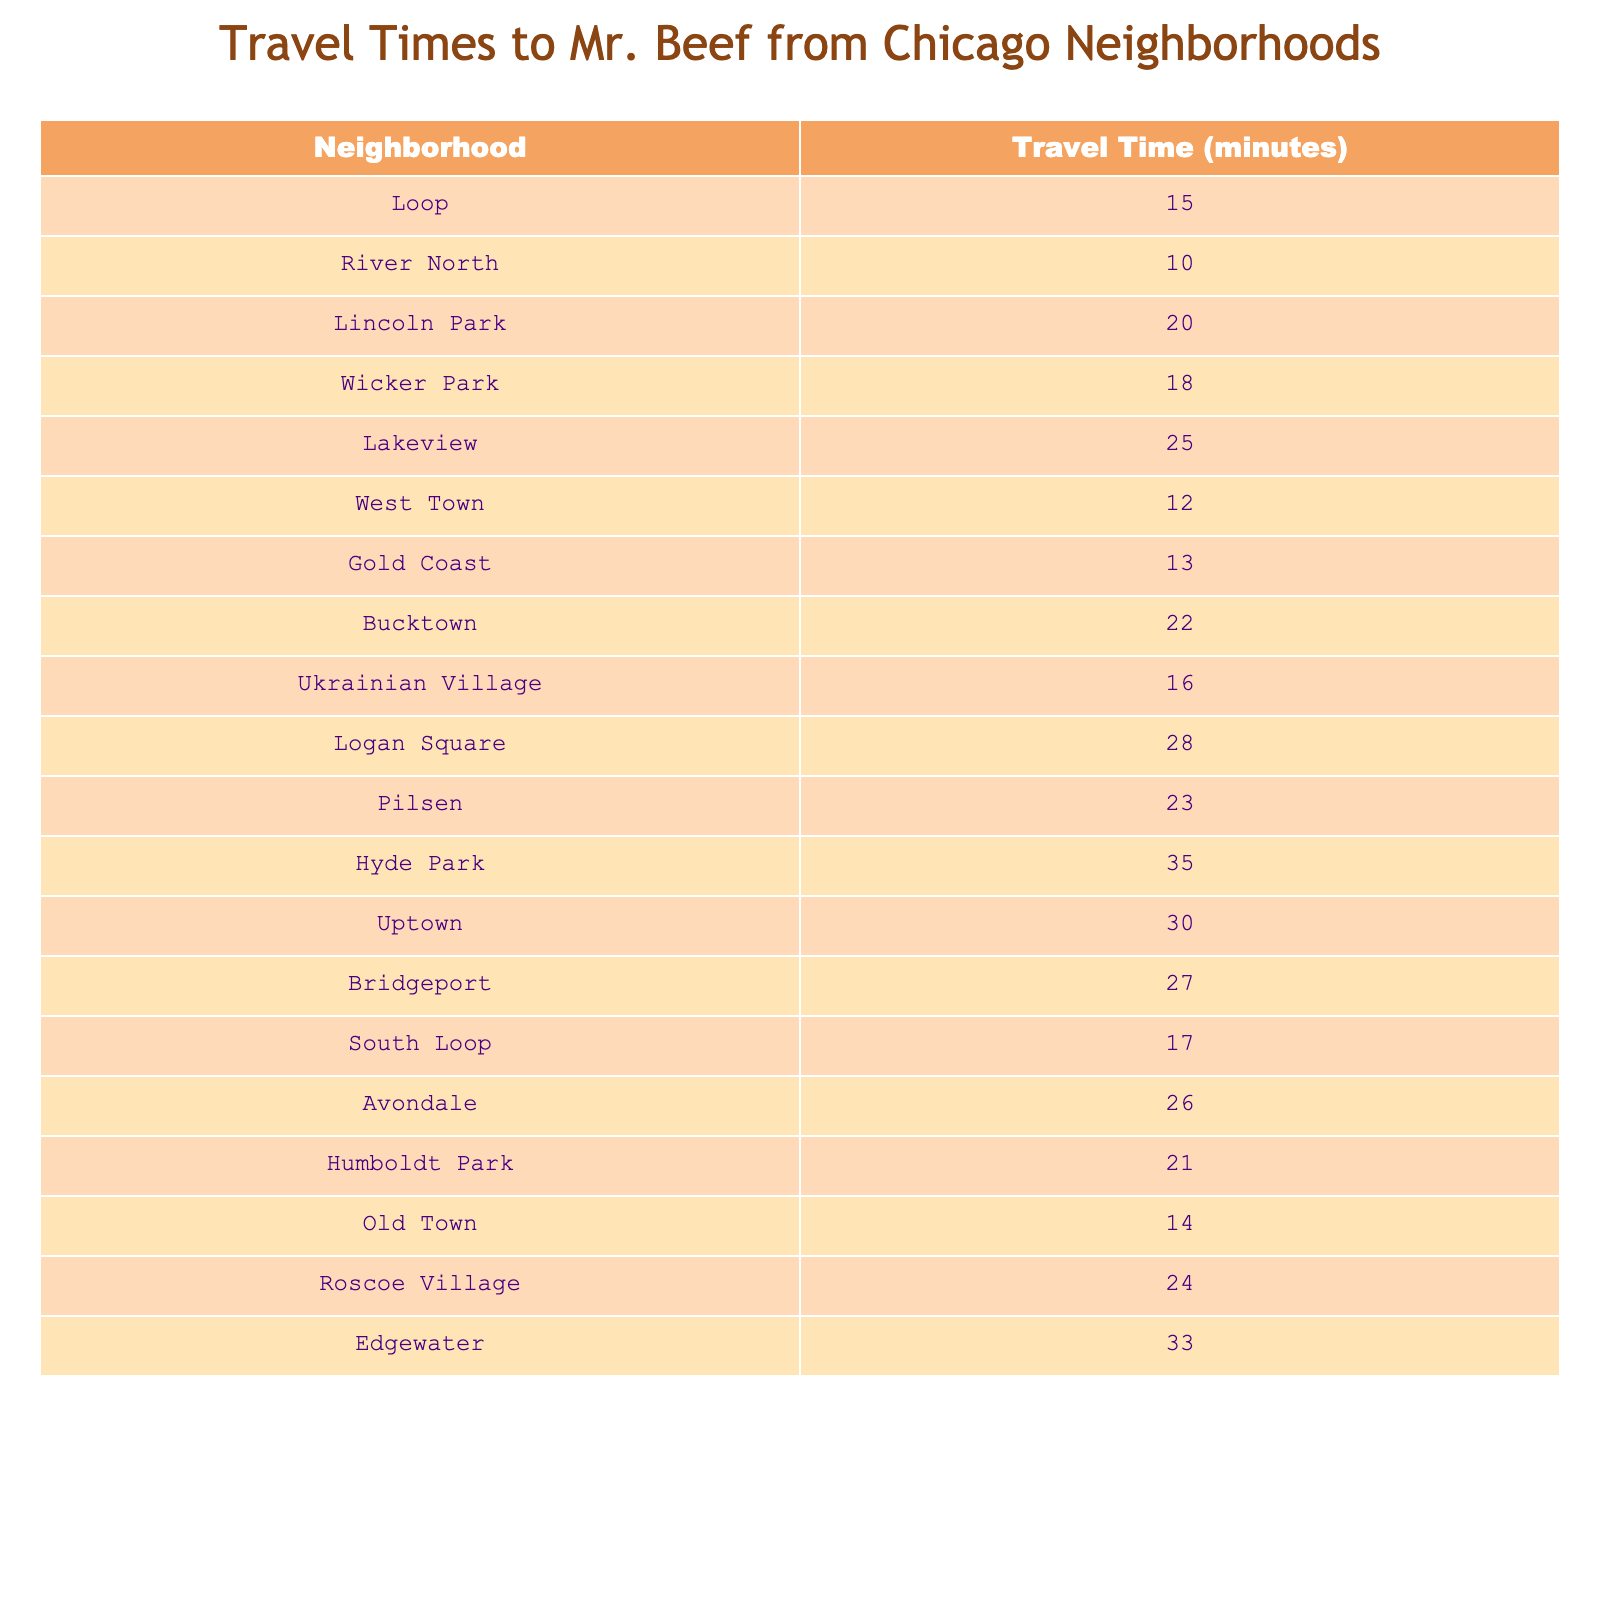What is the travel time from River North to Mr. Beef? The table lists the travel time from River North as 10 minutes.
Answer: 10 minutes Which neighborhood has the longest travel time to Mr. Beef? Logan Square has the longest travel time listed at 28 minutes.
Answer: Logan Square What is the average travel time for the neighborhoods listed? To find the average, sum the travel times of all neighborhoods (15 + 10 + 20 + 18 + 25 + 12 + 13 + 22 + 16 + 28 + 23 + 35 + 30 + 27 + 17 + 26 + 21 + 14 + 24 + 33 =  410) and divide by the total number of neighborhoods (20). Thus, the average is 410/20 = 20.5 minutes.
Answer: 20.5 minutes Is the travel time from Gold Coast less than 15 minutes? The travel time from Gold Coast is 13 minutes, which is less than 15 minutes.
Answer: Yes What is the difference in travel time between the fastest and slowest neighborhoods? The fastest neighborhood is River North with 10 minutes and the slowest is Hyde Park with 35 minutes. The difference is 35 - 10 = 25 minutes.
Answer: 25 minutes Which neighborhood is closer to Mr. Beef: West Town or Wicker Park? West Town has a travel time of 12 minutes, while Wicker Park has a travel time of 18 minutes. Since 12 is less than 18, West Town is closer.
Answer: West Town How many neighborhoods have a travel time longer than 25 minutes? The neighborhoods with travel times longer than 25 minutes are Hyde Park (35), Uptown (30), Bridgeport (27), and Edgewater (33), totaling 4 neighborhoods.
Answer: 4 neighborhoods What is the median travel time among the listed neighborhoods? To find the median, we first order the travel times: 10, 12, 13, 14, 15, 16, 17, 18, 20, 21, 22, 23, 24, 25, 26, 27, 28, 30, 33, 35. The median is the average of the 10th and 11th values (20 and 21), which is (20 + 21)/2 = 20.5 minutes.
Answer: 20.5 minutes Is there a neighborhood that has the same travel time as Lincoln Park? Lincoln Park has a travel time of 20 minutes. Checking the table, no other neighborhoods have the same travel time.
Answer: No What two neighborhoods have travel times that when added together equal 50 minutes? By inspecting the table, the neighborhoods of Lakeview (25 minutes) and Lincoln Park (20 minutes) sum to 50 (25 + 20 = 45). However, upon checking through pairs, Wicker Park (18) and Hyde Park (35) also sum to 53. No exact pairs are found.
Answer: None 